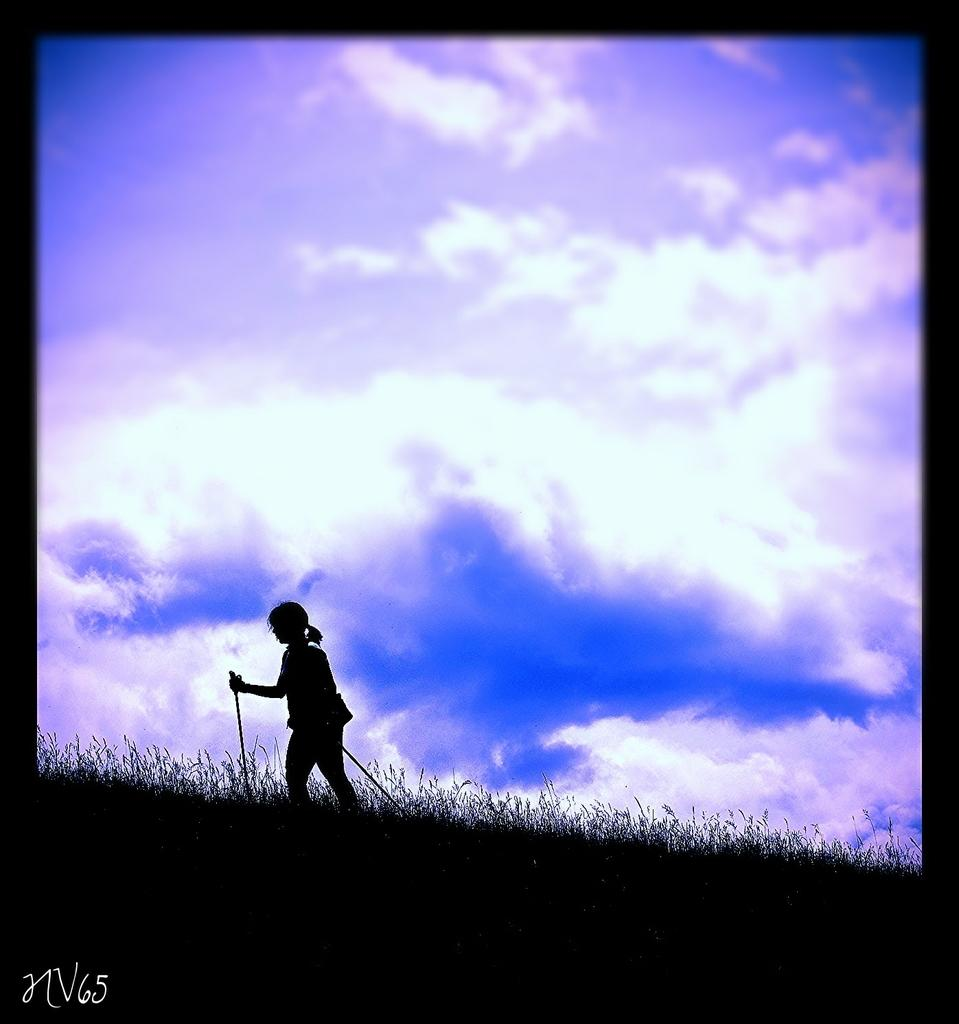Who is the main subject in the image? There is a girl in the image. What is the girl doing in the image? The girl is walking on the ground and holding sticks. What type of terrain is visible at the bottom of the image? There is grass at the bottom of the image. What is visible at the top of the image? The sky is visible at the top of the image, and there are clouds in the sky. What type of bell can be heard ringing in the image? There is no bell present in the image, and therefore no sound can be heard. 